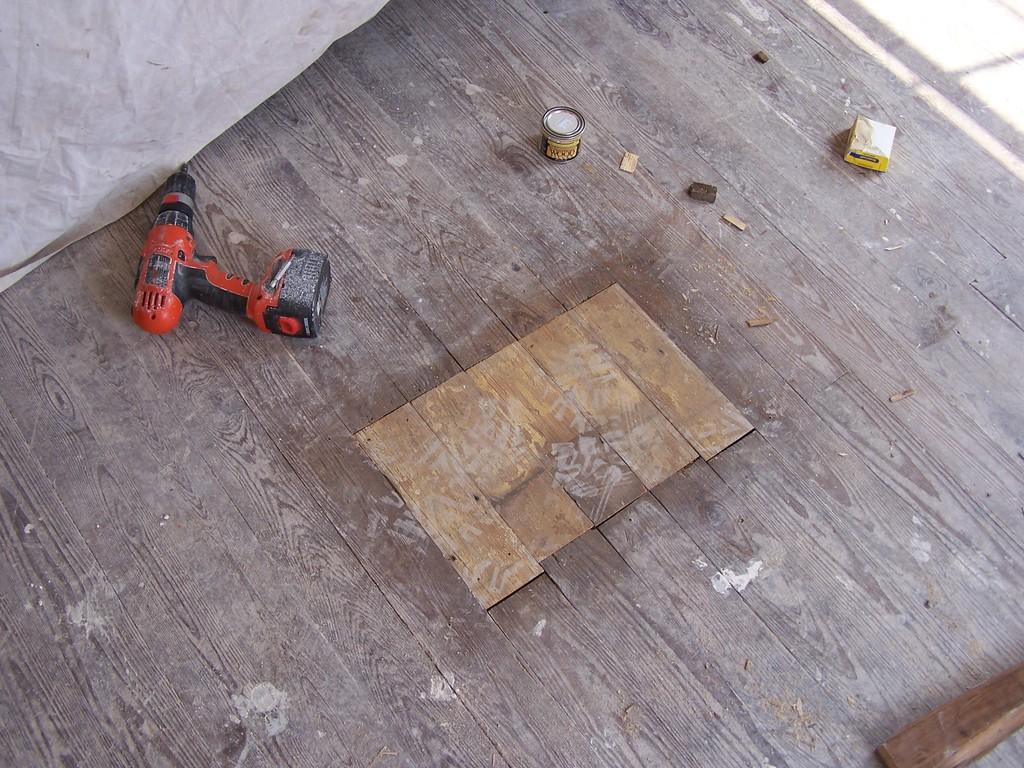What type of surface is visible in the image? There is a wooden surface in the image. What tool is placed on the wooden surface? There is a power drill on the wooden surface. What else can be seen on the wooden surface besides the power drill? There is a tin on the wooden surface, along with other items. What type of authority figure is depicted in the scene? There is no scene or authority figure present in the image; it only shows a wooden surface with a power drill and other items. 